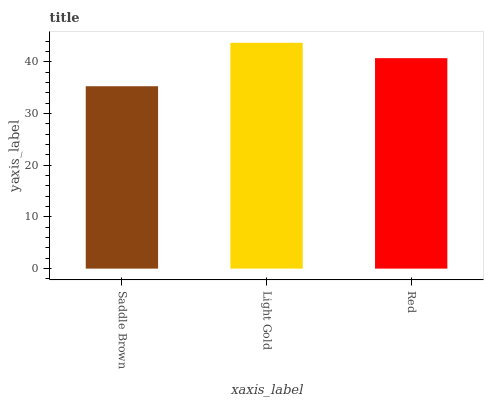Is Saddle Brown the minimum?
Answer yes or no. Yes. Is Light Gold the maximum?
Answer yes or no. Yes. Is Red the minimum?
Answer yes or no. No. Is Red the maximum?
Answer yes or no. No. Is Light Gold greater than Red?
Answer yes or no. Yes. Is Red less than Light Gold?
Answer yes or no. Yes. Is Red greater than Light Gold?
Answer yes or no. No. Is Light Gold less than Red?
Answer yes or no. No. Is Red the high median?
Answer yes or no. Yes. Is Red the low median?
Answer yes or no. Yes. Is Light Gold the high median?
Answer yes or no. No. Is Light Gold the low median?
Answer yes or no. No. 